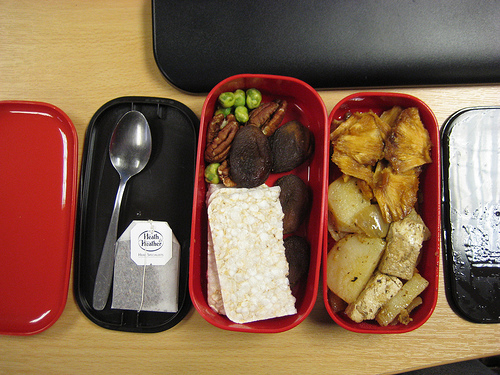<image>
Is there a lid under the tea? Yes. The lid is positioned underneath the tea, with the tea above it in the vertical space. 